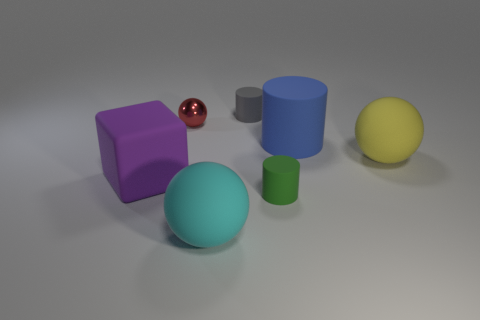Subtract all small red metallic balls. How many balls are left? 2 Subtract all balls. How many objects are left? 4 Subtract all cyan balls. How many balls are left? 2 Add 2 small brown cylinders. How many objects exist? 9 Subtract 2 cylinders. How many cylinders are left? 1 Subtract all cyan balls. Subtract all red cylinders. How many balls are left? 2 Subtract all cyan cylinders. How many blue balls are left? 0 Subtract all small cyan blocks. Subtract all cyan matte things. How many objects are left? 6 Add 5 red spheres. How many red spheres are left? 6 Add 1 large cubes. How many large cubes exist? 2 